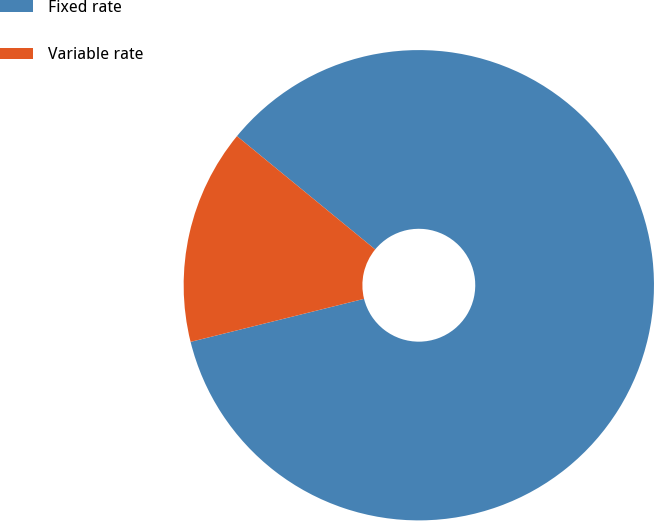<chart> <loc_0><loc_0><loc_500><loc_500><pie_chart><fcel>Fixed rate<fcel>Variable rate<nl><fcel>85.2%<fcel>14.8%<nl></chart> 